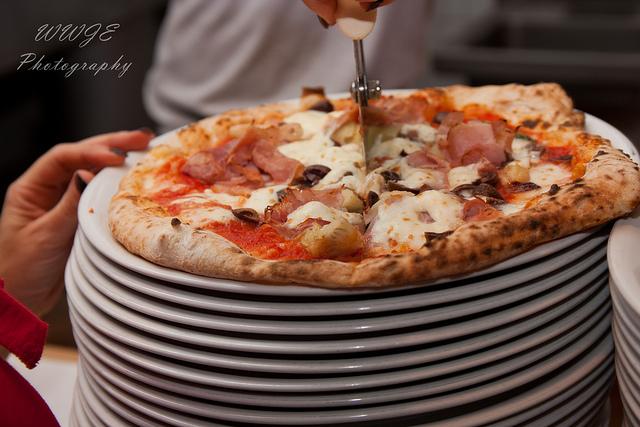What are they eating?
Answer briefly. Pizza. Does this pizza look greasy?
Write a very short answer. No. Is the left hand on the plates feminine?
Concise answer only. Yes. Do you need all these plates to serve one pizza?
Answer briefly. No. What type of meat is on the pizza?
Give a very brief answer. Ham. How many pizzas are ready?
Short answer required. 1. How many plates are there?
Give a very brief answer. 21. 